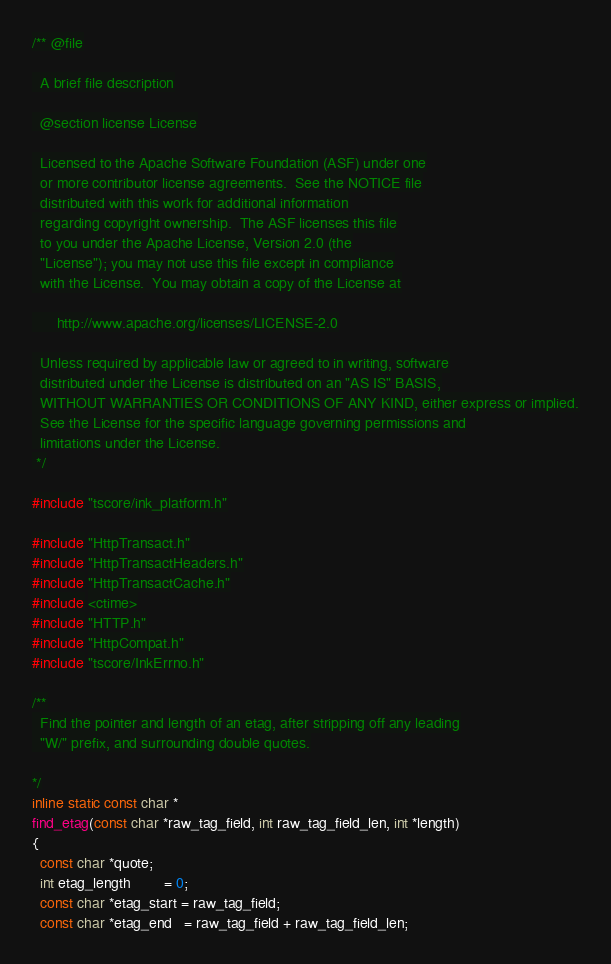<code> <loc_0><loc_0><loc_500><loc_500><_C++_>/** @file

  A brief file description

  @section license License

  Licensed to the Apache Software Foundation (ASF) under one
  or more contributor license agreements.  See the NOTICE file
  distributed with this work for additional information
  regarding copyright ownership.  The ASF licenses this file
  to you under the Apache License, Version 2.0 (the
  "License"); you may not use this file except in compliance
  with the License.  You may obtain a copy of the License at

      http://www.apache.org/licenses/LICENSE-2.0

  Unless required by applicable law or agreed to in writing, software
  distributed under the License is distributed on an "AS IS" BASIS,
  WITHOUT WARRANTIES OR CONDITIONS OF ANY KIND, either express or implied.
  See the License for the specific language governing permissions and
  limitations under the License.
 */

#include "tscore/ink_platform.h"

#include "HttpTransact.h"
#include "HttpTransactHeaders.h"
#include "HttpTransactCache.h"
#include <ctime>
#include "HTTP.h"
#include "HttpCompat.h"
#include "tscore/InkErrno.h"

/**
  Find the pointer and length of an etag, after stripping off any leading
  "W/" prefix, and surrounding double quotes.

*/
inline static const char *
find_etag(const char *raw_tag_field, int raw_tag_field_len, int *length)
{
  const char *quote;
  int etag_length        = 0;
  const char *etag_start = raw_tag_field;
  const char *etag_end   = raw_tag_field + raw_tag_field_len;
</code> 